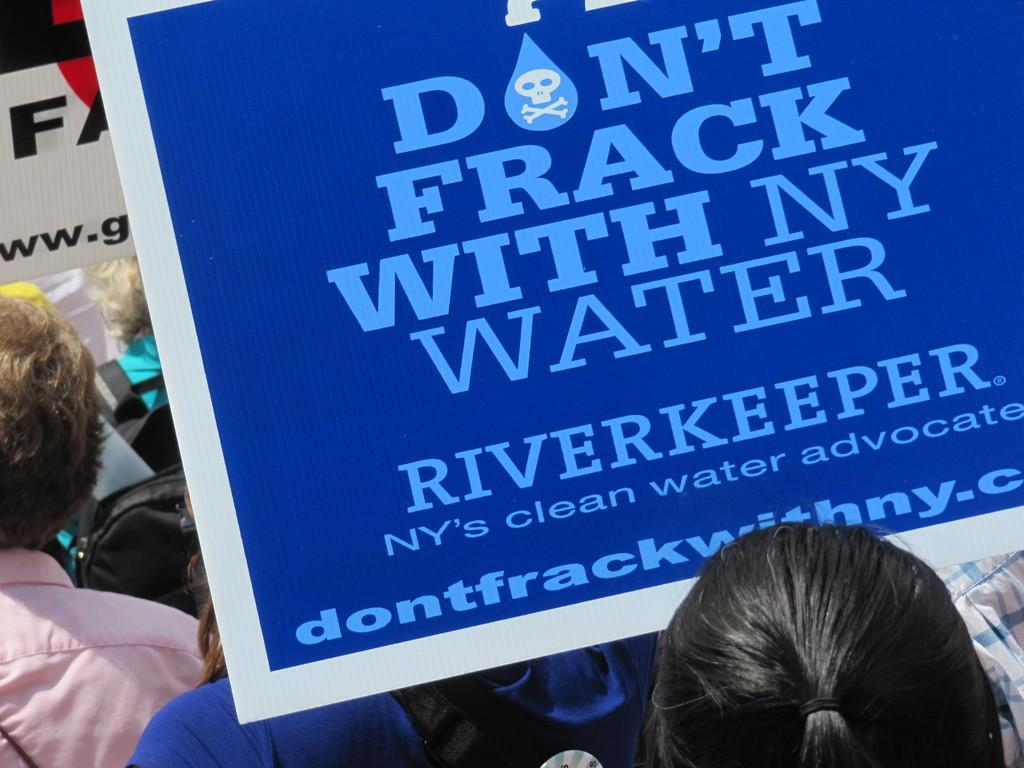What is the main subject of the image? The main subject of the image is a group of people. How can you describe the appearance of the people in the image? The people are wearing different color dresses. What are some people in the image carrying? There are people with bags in the image. What else can be seen in the image besides the people and their bags? There are boards in the image, and there is writing on the boards. What type of clouds can be seen in the image? There are no clouds visible in the image; it features a group of people, bags, and boards with writing. Are the people wearing jeans in the image? The facts provided do not mention the type of pants the people are wearing, so it cannot be determined if they are wearing jeans or not. 